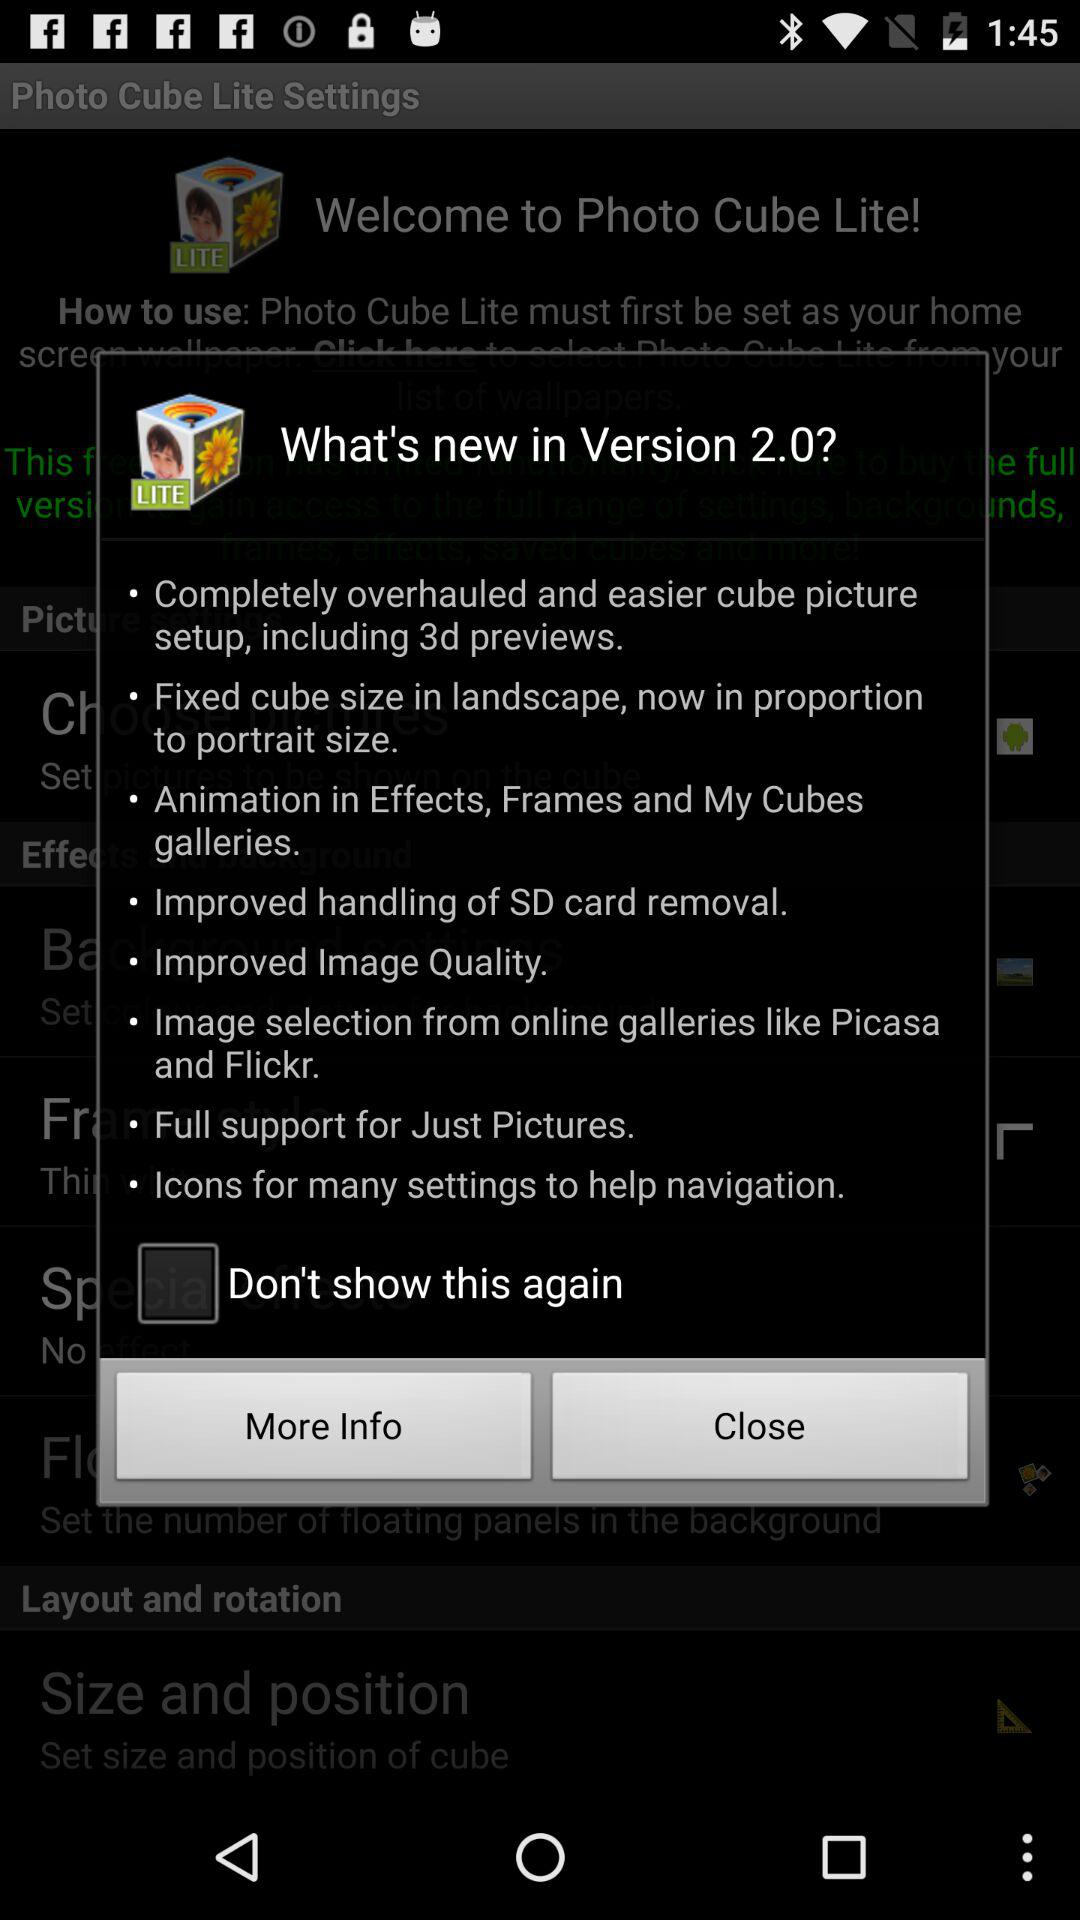What is the status of "Don't show this again"? The status is "off". 